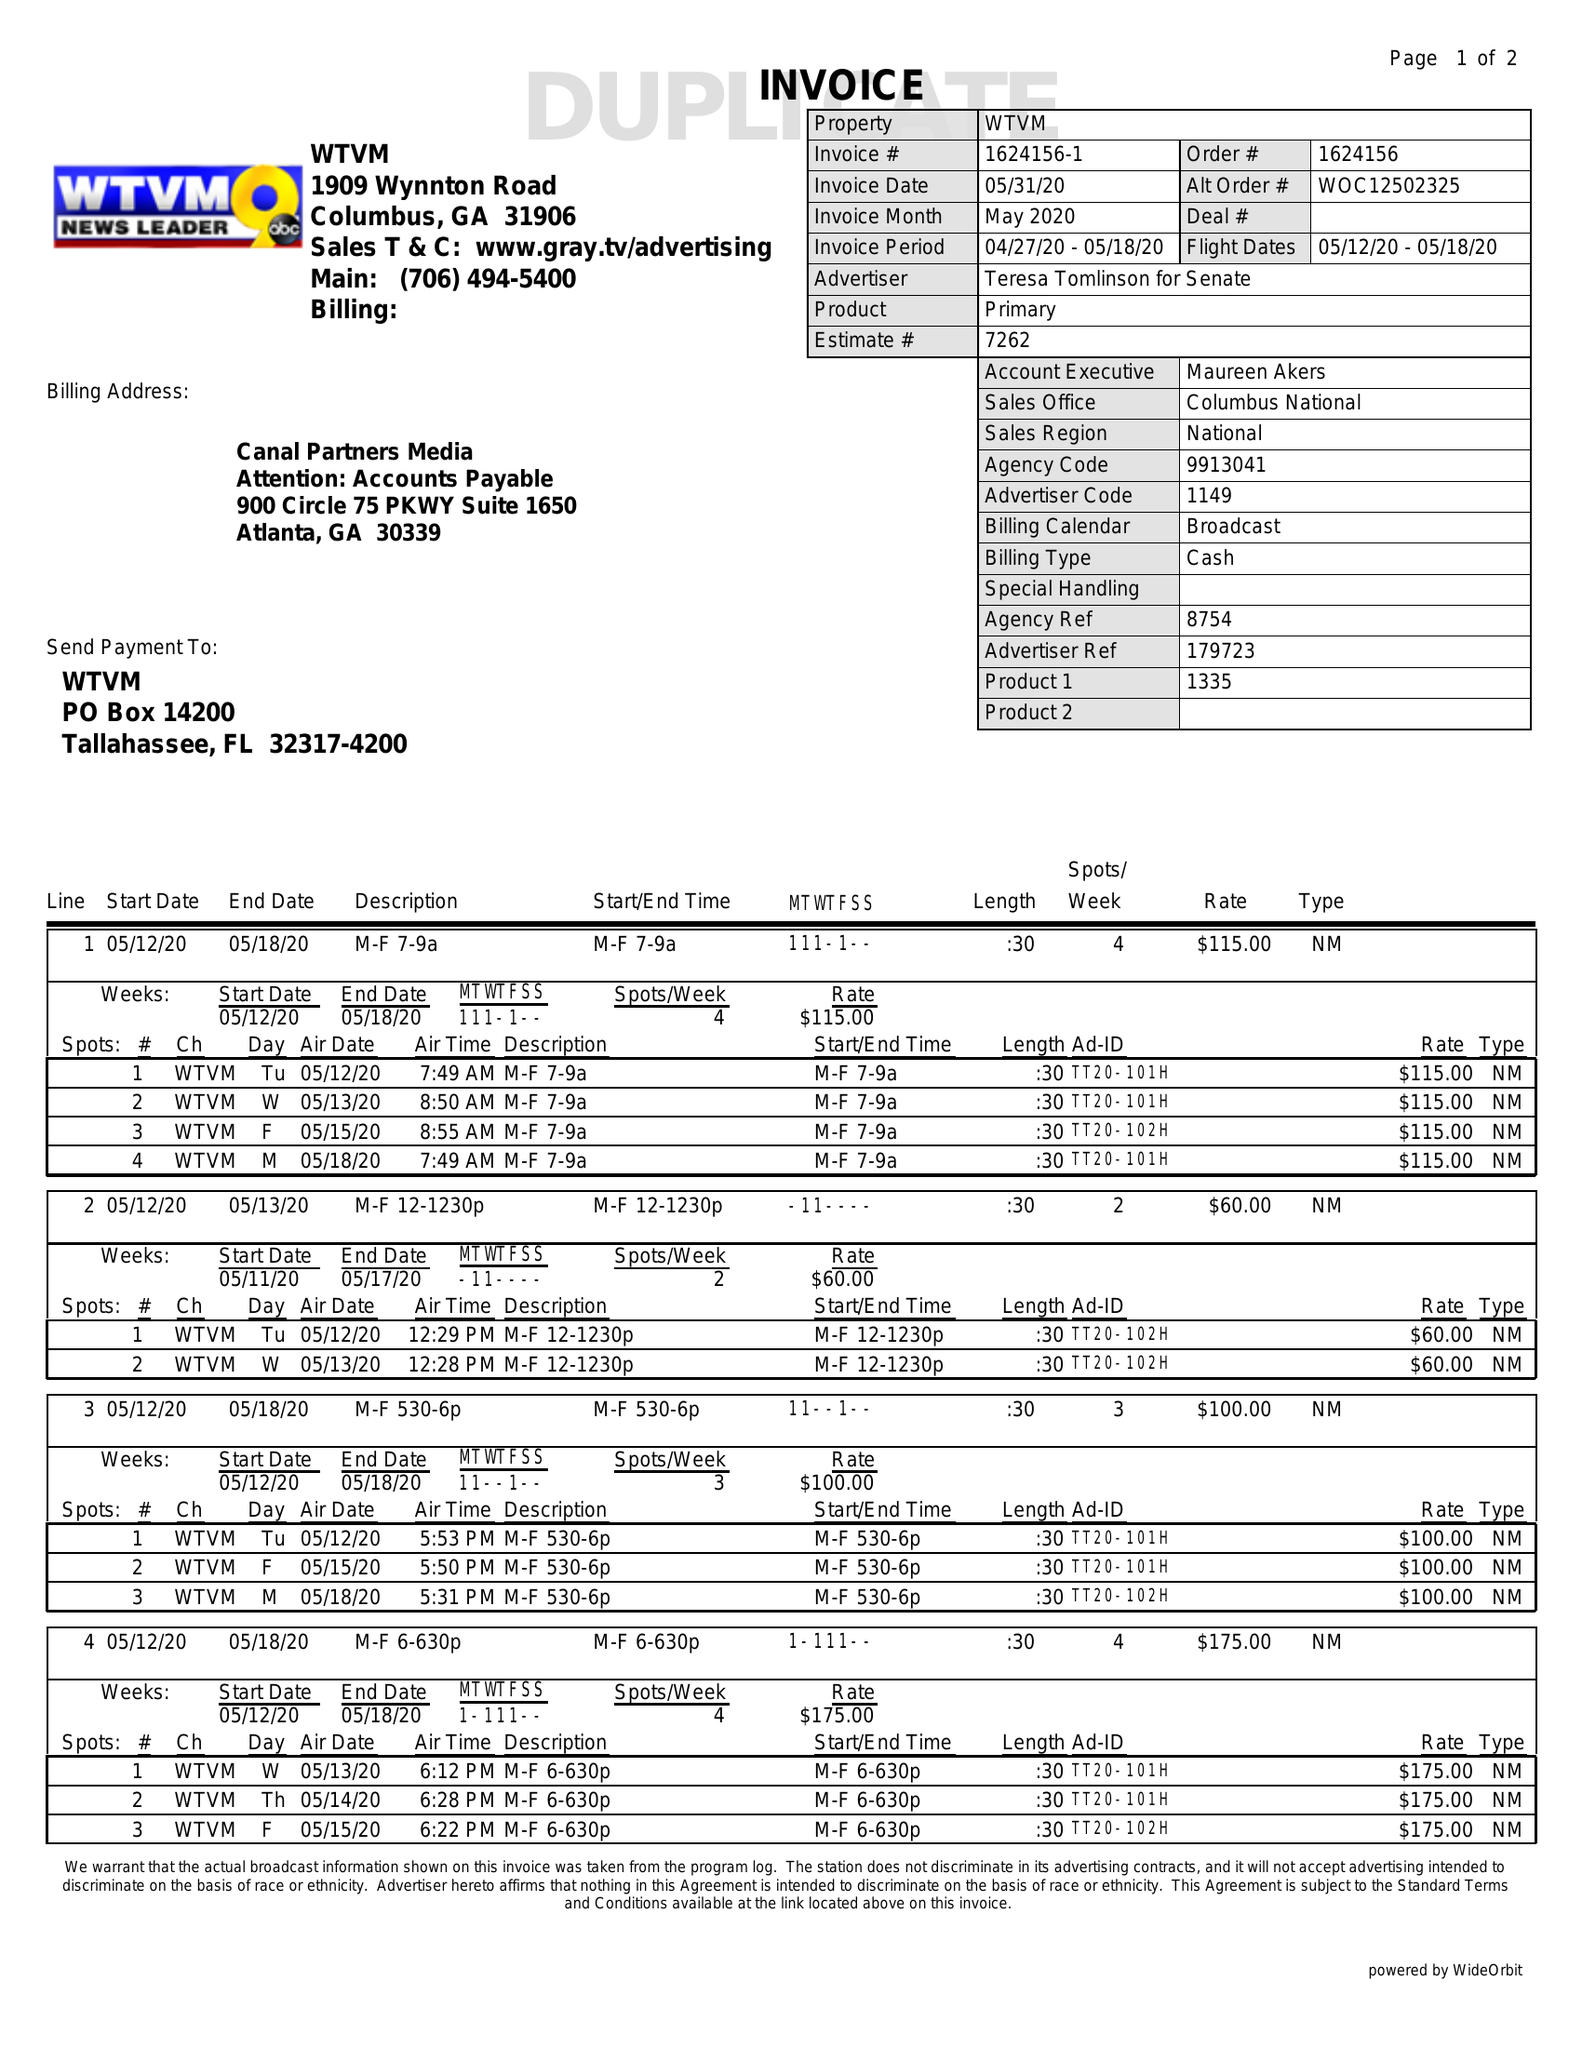What is the value for the contract_num?
Answer the question using a single word or phrase. 1624156 